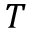<formula> <loc_0><loc_0><loc_500><loc_500>T</formula> 